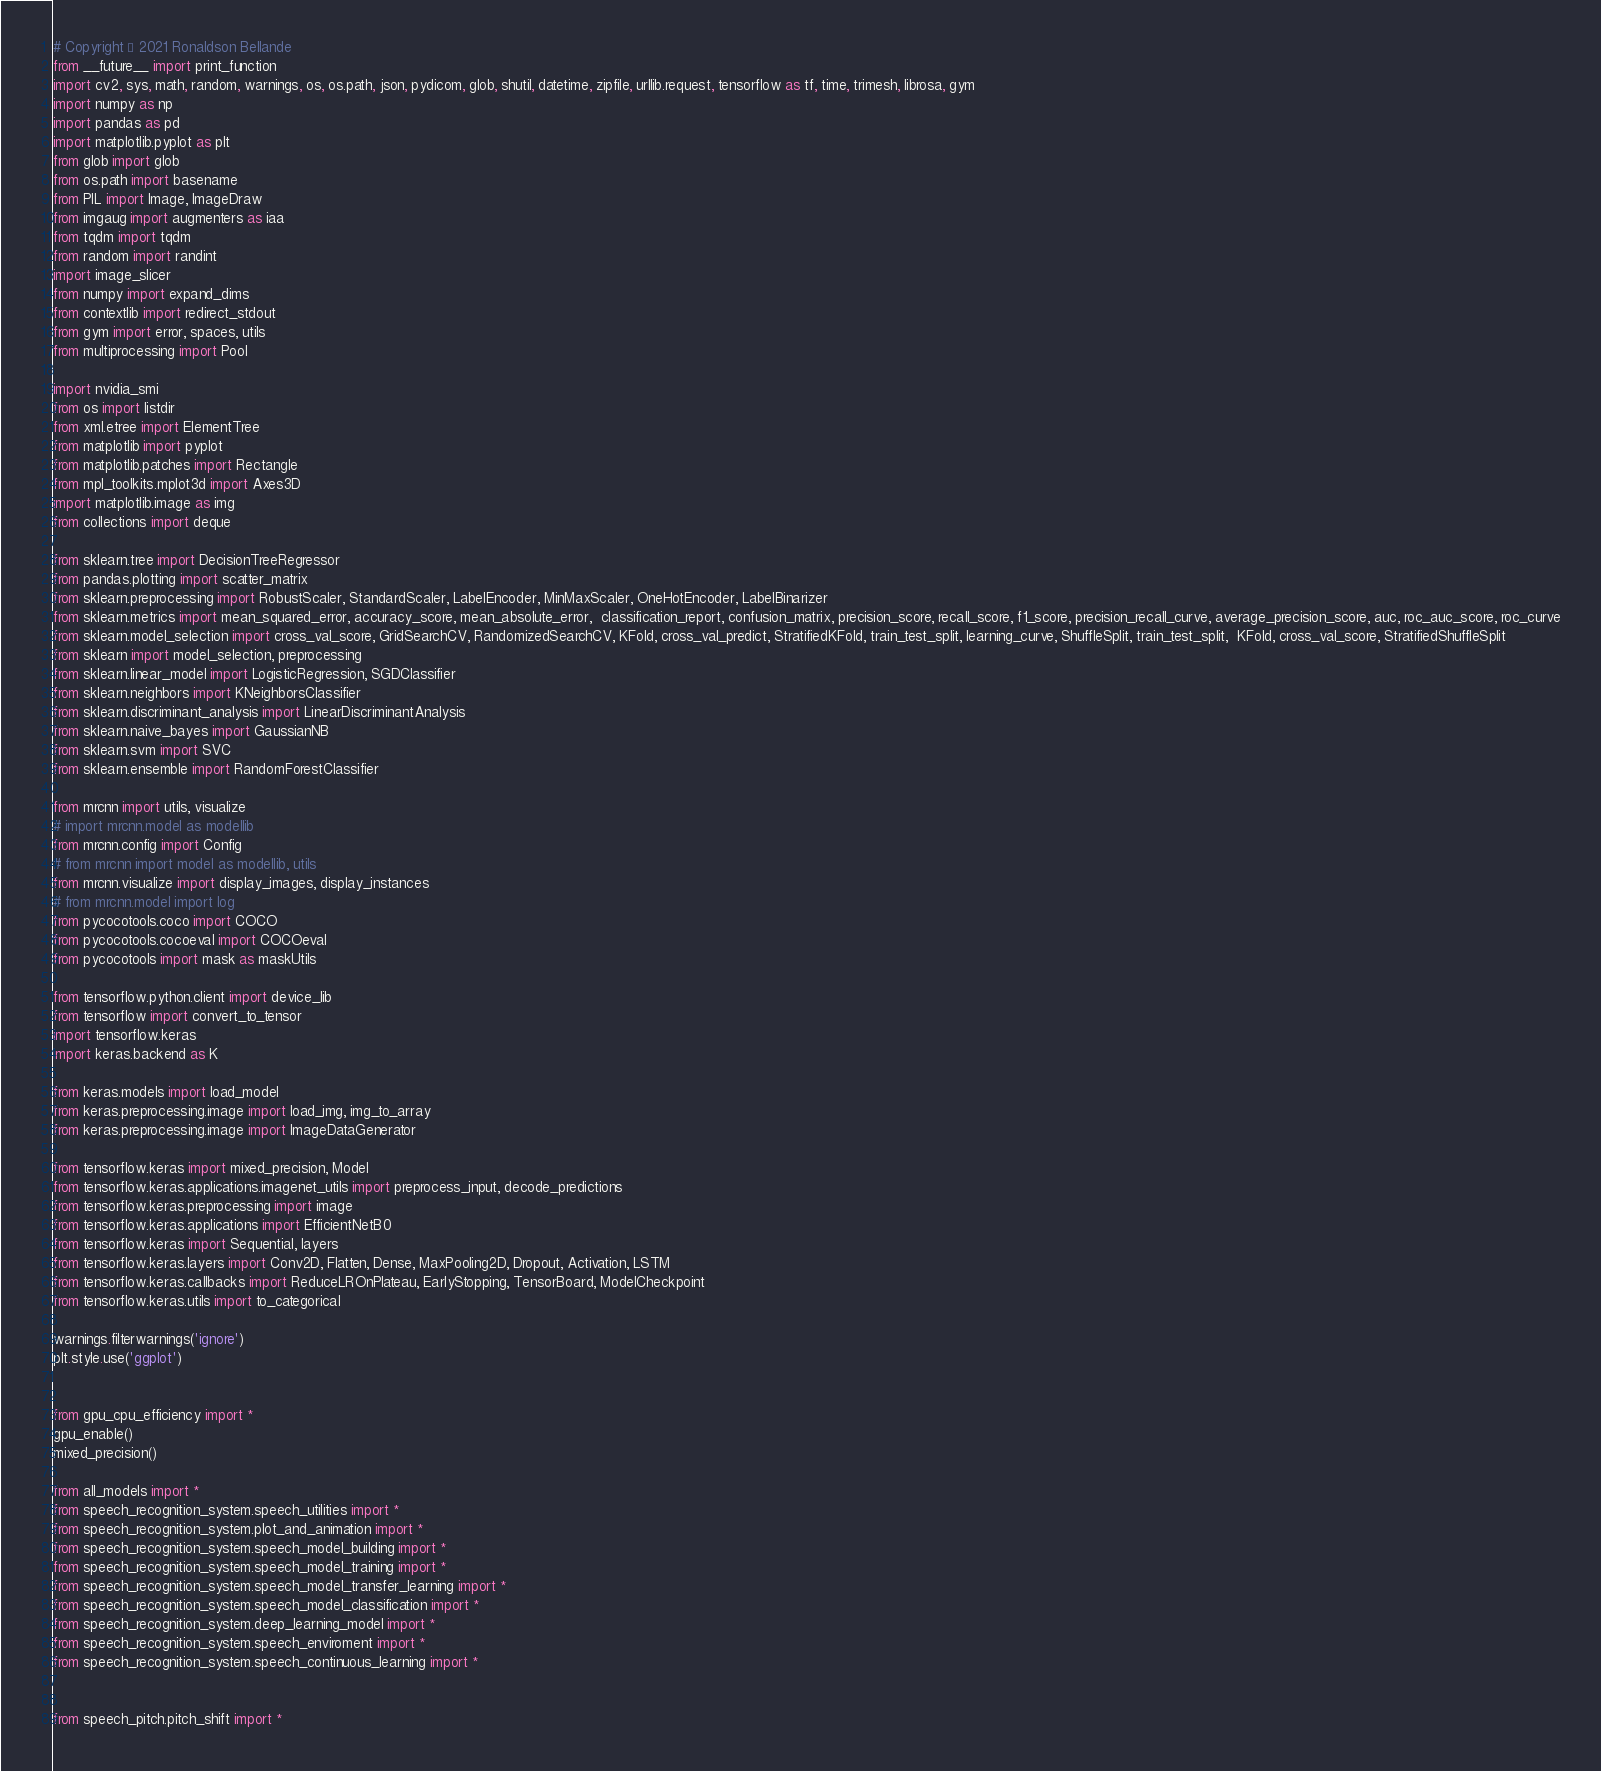<code> <loc_0><loc_0><loc_500><loc_500><_Python_># Copyright © 2021 Ronaldson Bellande
from __future__ import print_function
import cv2, sys, math, random, warnings, os, os.path, json, pydicom, glob, shutil, datetime, zipfile, urllib.request, tensorflow as tf, time, trimesh, librosa, gym
import numpy as np
import pandas as pd
import matplotlib.pyplot as plt
from glob import glob
from os.path import basename
from PIL import Image, ImageDraw
from imgaug import augmenters as iaa
from tqdm import tqdm
from random import randint
import image_slicer
from numpy import expand_dims
from contextlib import redirect_stdout
from gym import error, spaces, utils
from multiprocessing import Pool

import nvidia_smi
from os import listdir
from xml.etree import ElementTree
from matplotlib import pyplot
from matplotlib.patches import Rectangle
from mpl_toolkits.mplot3d import Axes3D
import matplotlib.image as img
from collections import deque

from sklearn.tree import DecisionTreeRegressor
from pandas.plotting import scatter_matrix
from sklearn.preprocessing import RobustScaler, StandardScaler, LabelEncoder, MinMaxScaler, OneHotEncoder, LabelBinarizer
from sklearn.metrics import mean_squared_error, accuracy_score, mean_absolute_error,  classification_report, confusion_matrix, precision_score, recall_score, f1_score, precision_recall_curve, average_precision_score, auc, roc_auc_score, roc_curve
from sklearn.model_selection import cross_val_score, GridSearchCV, RandomizedSearchCV, KFold, cross_val_predict, StratifiedKFold, train_test_split, learning_curve, ShuffleSplit, train_test_split,  KFold, cross_val_score, StratifiedShuffleSplit
from sklearn import model_selection, preprocessing
from sklearn.linear_model import LogisticRegression, SGDClassifier
from sklearn.neighbors import KNeighborsClassifier
from sklearn.discriminant_analysis import LinearDiscriminantAnalysis
from sklearn.naive_bayes import GaussianNB
from sklearn.svm import SVC 
from sklearn.ensemble import RandomForestClassifier

from mrcnn import utils, visualize
# import mrcnn.model as modellib
from mrcnn.config import Config
# from mrcnn import model as modellib, utils
from mrcnn.visualize import display_images, display_instances
# from mrcnn.model import log
from pycocotools.coco import COCO
from pycocotools.cocoeval import COCOeval
from pycocotools import mask as maskUtils

from tensorflow.python.client import device_lib
from tensorflow import convert_to_tensor
import tensorflow.keras
import keras.backend as K

from keras.models import load_model
from keras.preprocessing.image import load_img, img_to_array
from keras.preprocessing.image import ImageDataGenerator

from tensorflow.keras import mixed_precision, Model
from tensorflow.keras.applications.imagenet_utils import preprocess_input, decode_predictions
from tensorflow.keras.preprocessing import image
from tensorflow.keras.applications import EfficientNetB0
from tensorflow.keras import Sequential, layers
from tensorflow.keras.layers import Conv2D, Flatten, Dense, MaxPooling2D, Dropout, Activation, LSTM
from tensorflow.keras.callbacks import ReduceLROnPlateau, EarlyStopping, TensorBoard, ModelCheckpoint
from tensorflow.keras.utils import to_categorical

warnings.filterwarnings('ignore')
plt.style.use('ggplot')


from gpu_cpu_efficiency import *
gpu_enable()
mixed_precision()

from all_models import *
from speech_recognition_system.speech_utilities import *
from speech_recognition_system.plot_and_animation import *
from speech_recognition_system.speech_model_building import *
from speech_recognition_system.speech_model_training import *
from speech_recognition_system.speech_model_transfer_learning import *
from speech_recognition_system.speech_model_classification import *
from speech_recognition_system.deep_learning_model import *
from speech_recognition_system.speech_enviroment import *
from speech_recognition_system.speech_continuous_learning import *


from speech_pitch.pitch_shift import *
</code> 